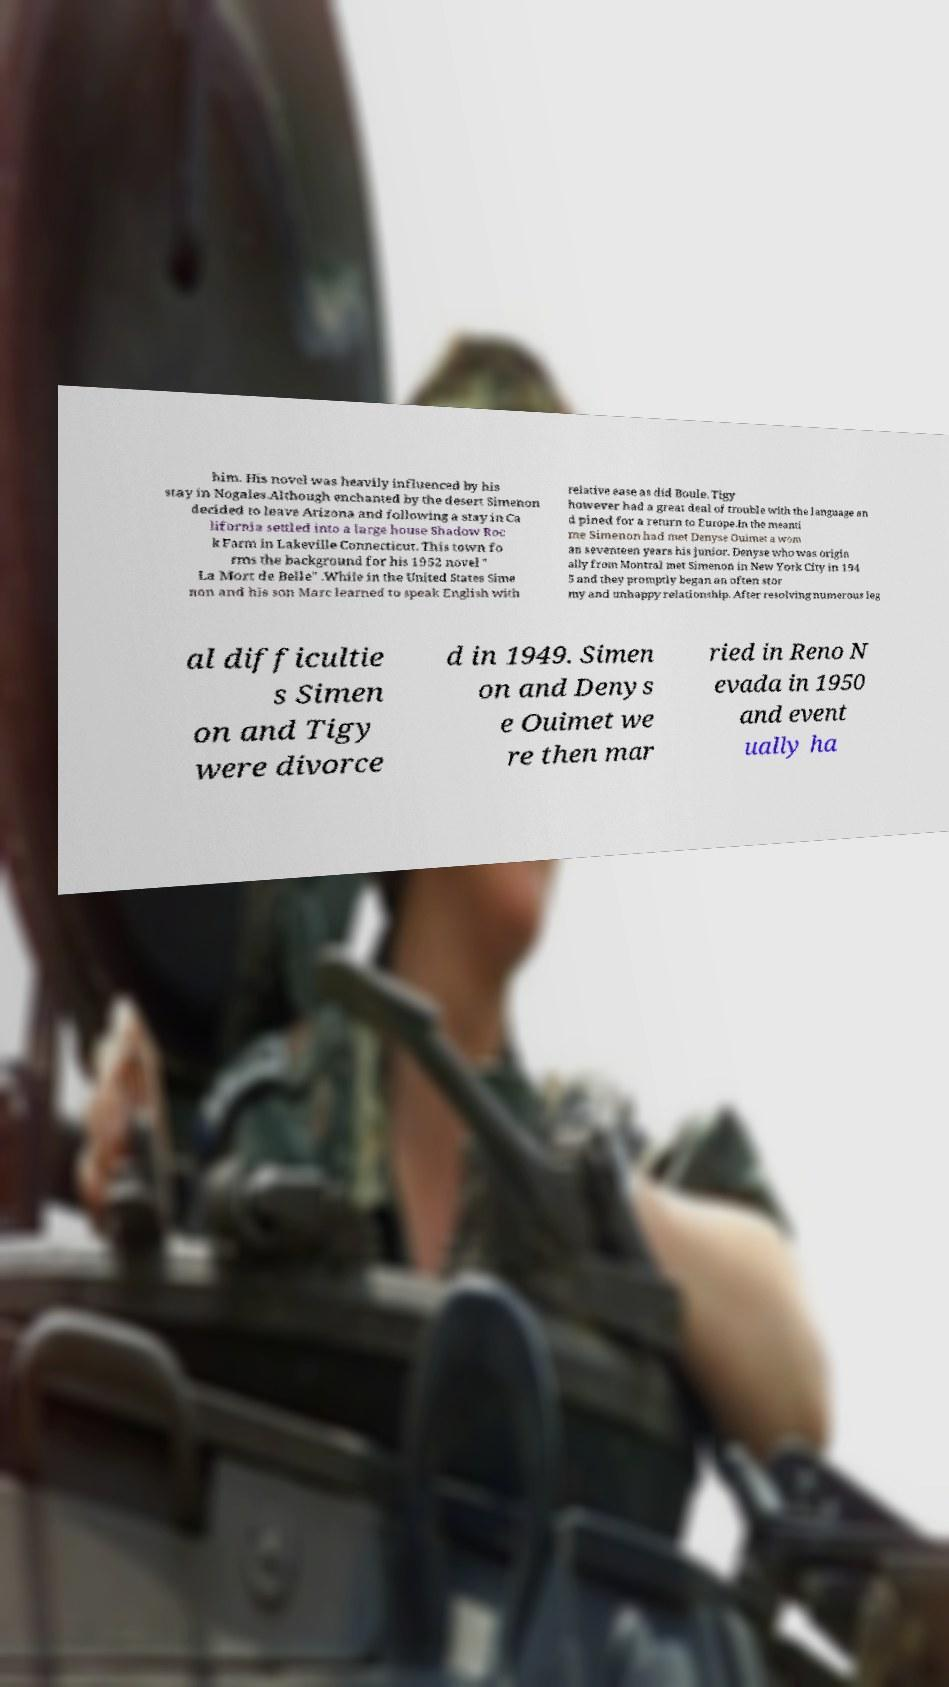I need the written content from this picture converted into text. Can you do that? him. His novel was heavily influenced by his stay in Nogales.Although enchanted by the desert Simenon decided to leave Arizona and following a stay in Ca lifornia settled into a large house Shadow Roc k Farm in Lakeville Connecticut. This town fo rms the background for his 1952 novel " La Mort de Belle" .While in the United States Sime non and his son Marc learned to speak English with relative ease as did Boule. Tigy however had a great deal of trouble with the language an d pined for a return to Europe.In the meanti me Simenon had met Denyse Ouimet a wom an seventeen years his junior. Denyse who was origin ally from Montral met Simenon in New York City in 194 5 and they promptly began an often stor my and unhappy relationship. After resolving numerous leg al difficultie s Simen on and Tigy were divorce d in 1949. Simen on and Denys e Ouimet we re then mar ried in Reno N evada in 1950 and event ually ha 